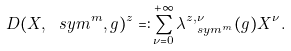Convert formula to latex. <formula><loc_0><loc_0><loc_500><loc_500>D ( X , \ s y m ^ { m } , g ) ^ { z } = \colon \sum _ { \nu = 0 } ^ { + \infty } \lambda _ { \ s y m ^ { m } } ^ { z , \nu } ( g ) X ^ { \nu } .</formula> 